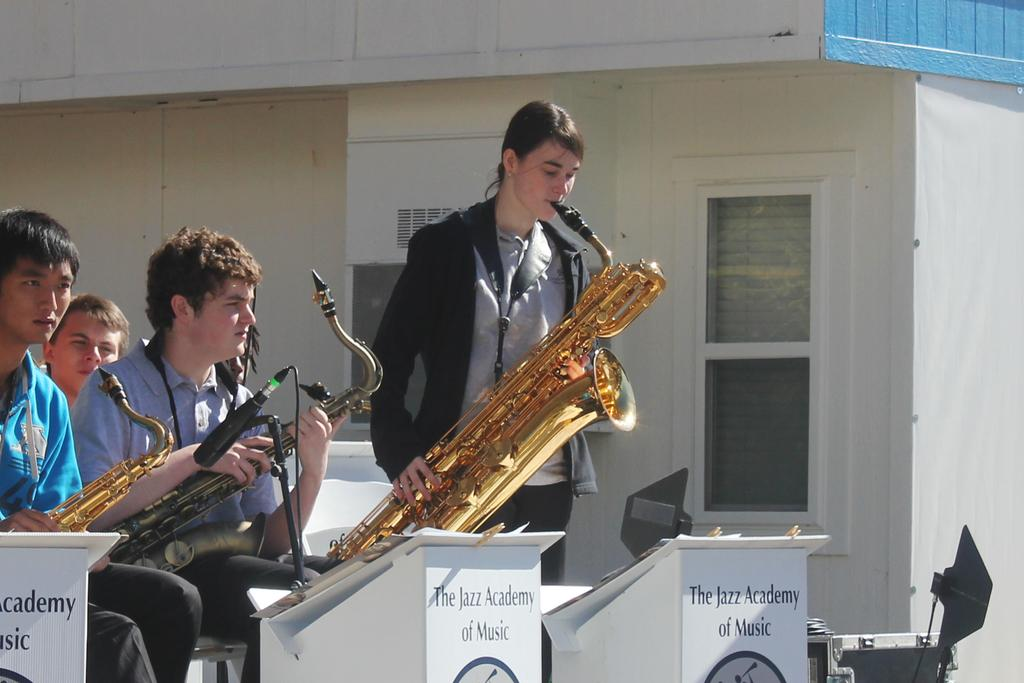<image>
Render a clear and concise summary of the photo. A young student from the Jazz Academy of Music plays a trumpet solo at a concert. 